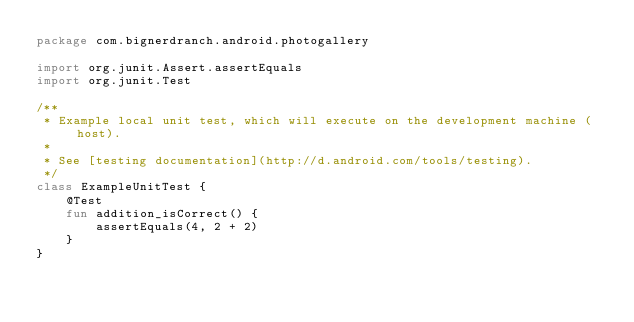<code> <loc_0><loc_0><loc_500><loc_500><_Kotlin_>package com.bignerdranch.android.photogallery

import org.junit.Assert.assertEquals
import org.junit.Test

/**
 * Example local unit test, which will execute on the development machine (host).
 *
 * See [testing documentation](http://d.android.com/tools/testing).
 */
class ExampleUnitTest {
    @Test
    fun addition_isCorrect() {
        assertEquals(4, 2 + 2)
    }
}
</code> 